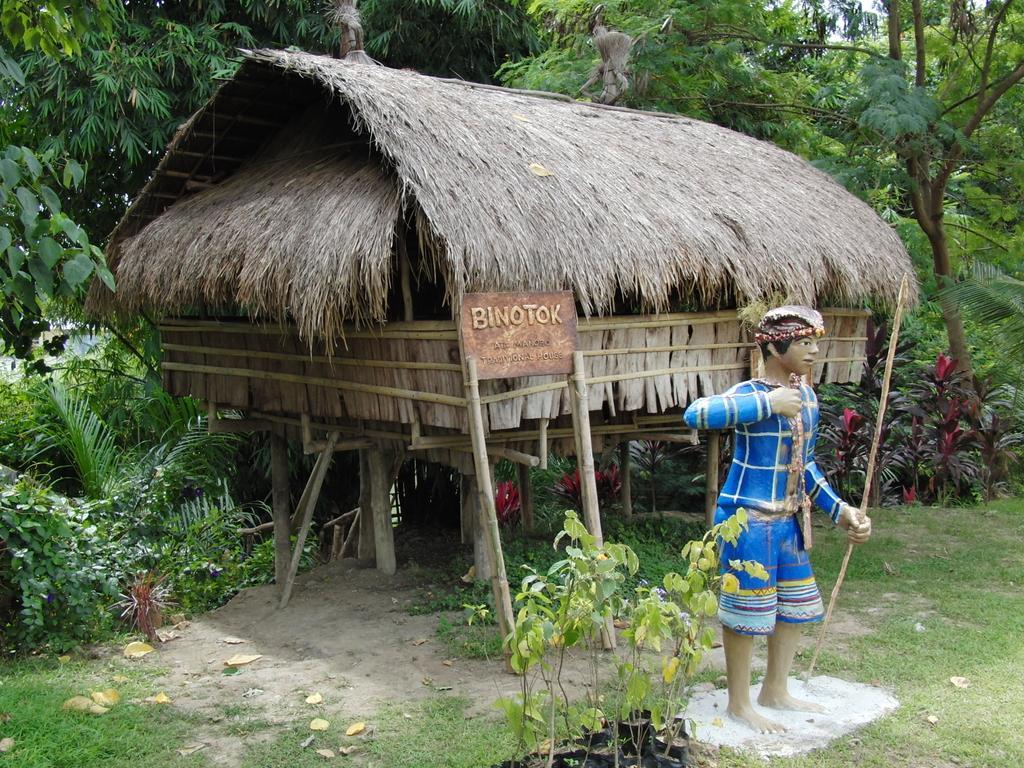Can you describe this image briefly? In this image we can see many trees and plants. There is a grassy land in the image. There is a sculpture in the image. There is a hut in the image. 